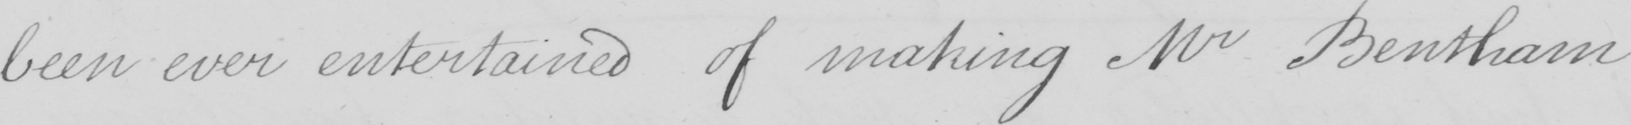Transcribe the text shown in this historical manuscript line. been ever entertained of making Mr Bentham 